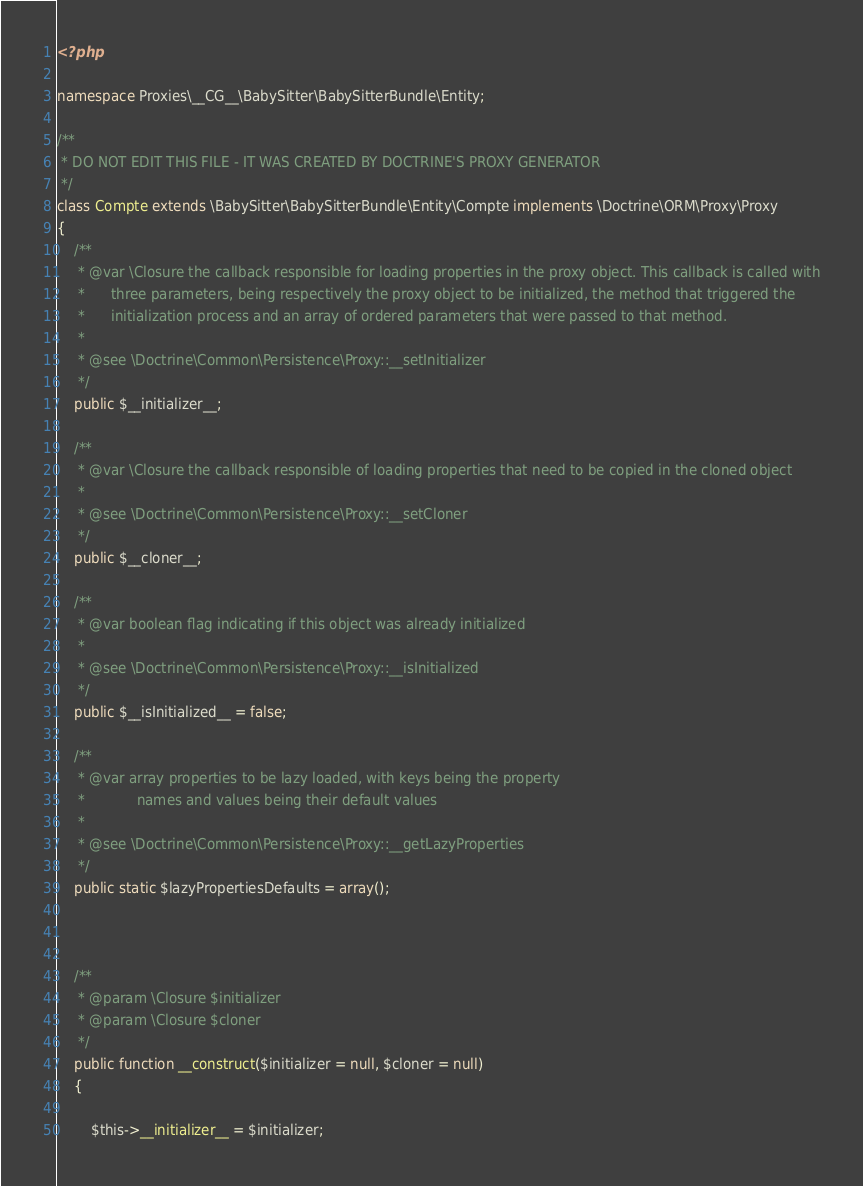Convert code to text. <code><loc_0><loc_0><loc_500><loc_500><_PHP_><?php

namespace Proxies\__CG__\BabySitter\BabySitterBundle\Entity;

/**
 * DO NOT EDIT THIS FILE - IT WAS CREATED BY DOCTRINE'S PROXY GENERATOR
 */
class Compte extends \BabySitter\BabySitterBundle\Entity\Compte implements \Doctrine\ORM\Proxy\Proxy
{
    /**
     * @var \Closure the callback responsible for loading properties in the proxy object. This callback is called with
     *      three parameters, being respectively the proxy object to be initialized, the method that triggered the
     *      initialization process and an array of ordered parameters that were passed to that method.
     *
     * @see \Doctrine\Common\Persistence\Proxy::__setInitializer
     */
    public $__initializer__;

    /**
     * @var \Closure the callback responsible of loading properties that need to be copied in the cloned object
     *
     * @see \Doctrine\Common\Persistence\Proxy::__setCloner
     */
    public $__cloner__;

    /**
     * @var boolean flag indicating if this object was already initialized
     *
     * @see \Doctrine\Common\Persistence\Proxy::__isInitialized
     */
    public $__isInitialized__ = false;

    /**
     * @var array properties to be lazy loaded, with keys being the property
     *            names and values being their default values
     *
     * @see \Doctrine\Common\Persistence\Proxy::__getLazyProperties
     */
    public static $lazyPropertiesDefaults = array();



    /**
     * @param \Closure $initializer
     * @param \Closure $cloner
     */
    public function __construct($initializer = null, $cloner = null)
    {

        $this->__initializer__ = $initializer;</code> 